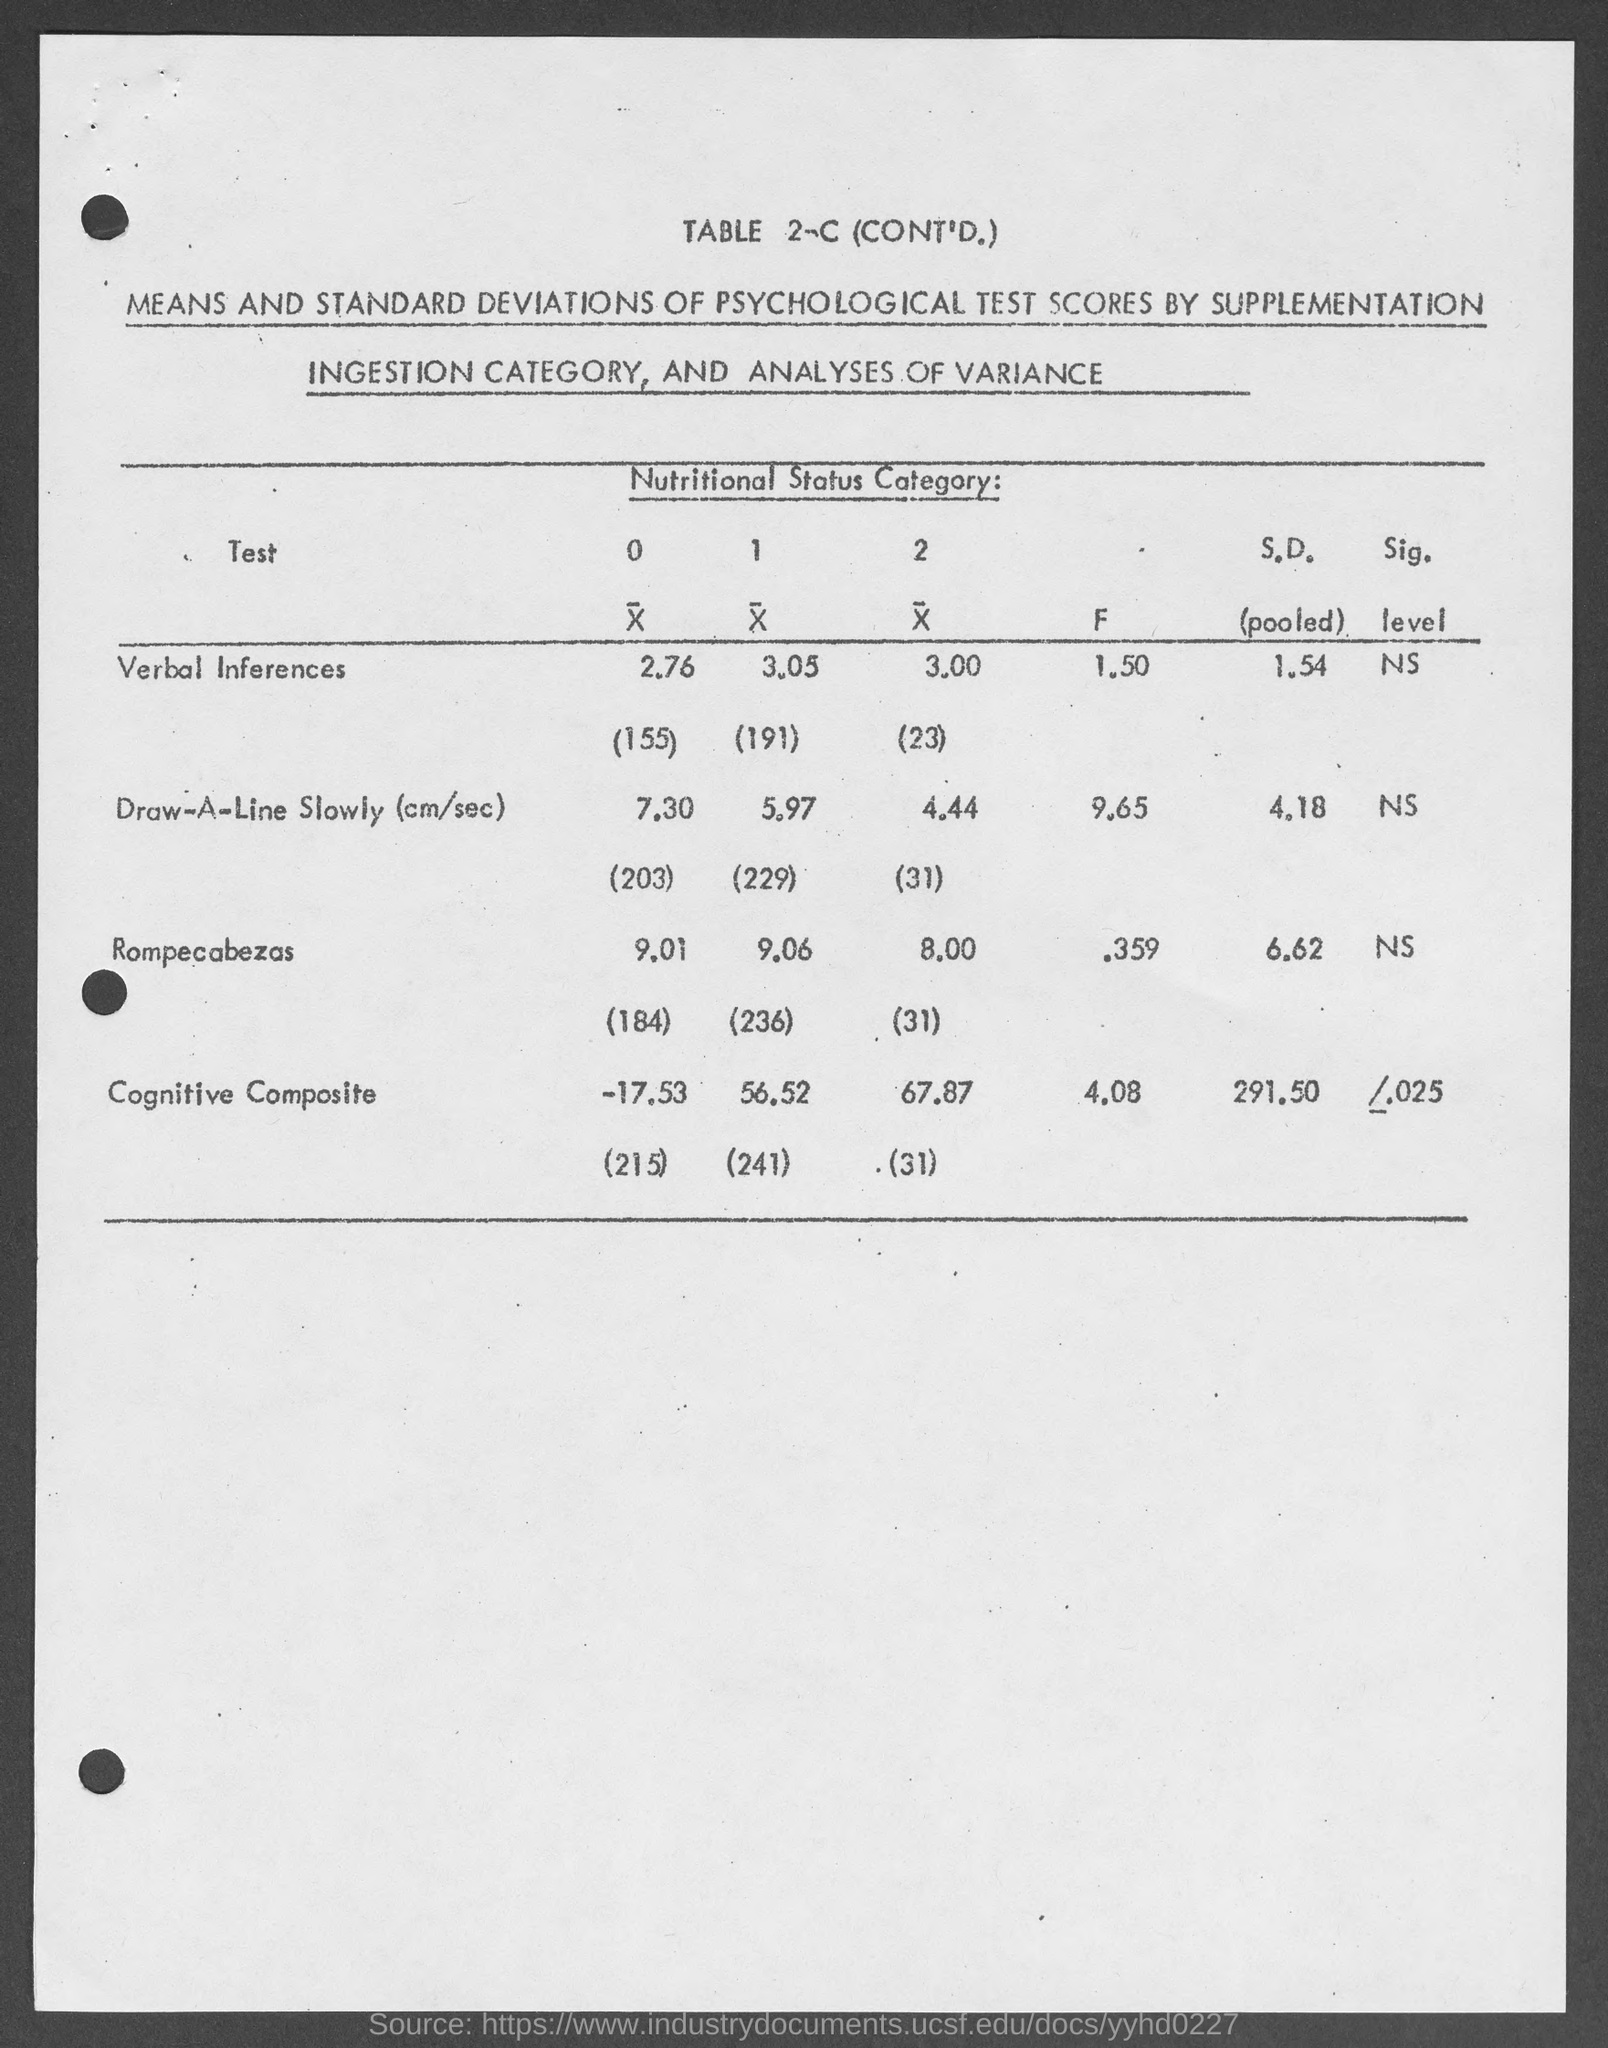What is the table no.?
Your response must be concise. 2-c. What is the s.d.  (pooled) for verbal inferences ?
Make the answer very short. 1.54. What is the s.d.  (pooled) for draw-a-line slowly ( cm/sec)?
Make the answer very short. 4.18. What is the s.d.  (pooled) for rompecabezas ?
Your answer should be very brief. 6.62. What is the s.d.  (pooled) for cognitive composite ?
Offer a terse response. 291.50. What is the f value for verbal inferences ?
Make the answer very short. 1.50. What is the f value for draw-a-line slowly (cm/sec) ?
Provide a short and direct response. 9.65. What is the f value for rompecabezas ?
Your answer should be compact. .359. What is the f value for cognitive composite ?
Make the answer very short. 4.08. 